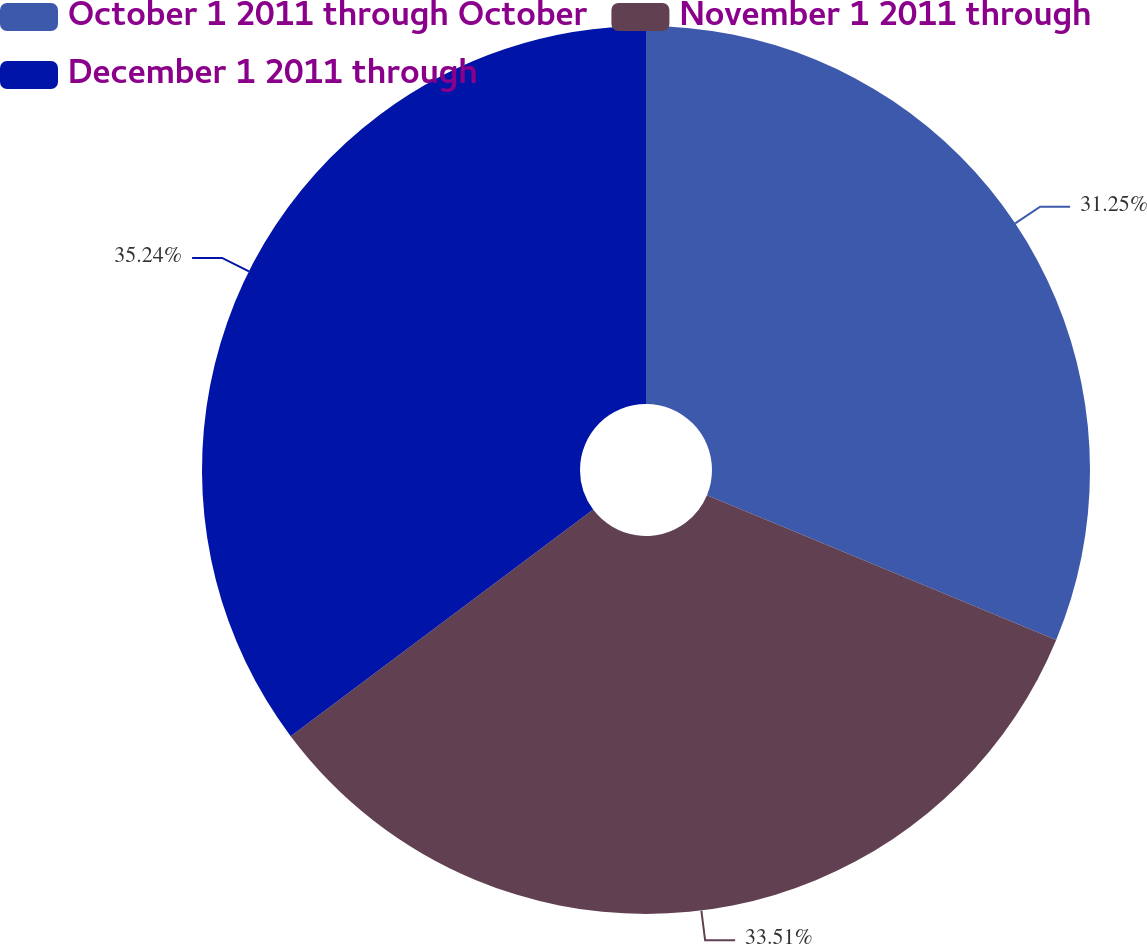Convert chart. <chart><loc_0><loc_0><loc_500><loc_500><pie_chart><fcel>October 1 2011 through October<fcel>November 1 2011 through<fcel>December 1 2011 through<nl><fcel>31.25%<fcel>33.51%<fcel>35.23%<nl></chart> 